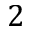Convert formula to latex. <formula><loc_0><loc_0><loc_500><loc_500>2</formula> 